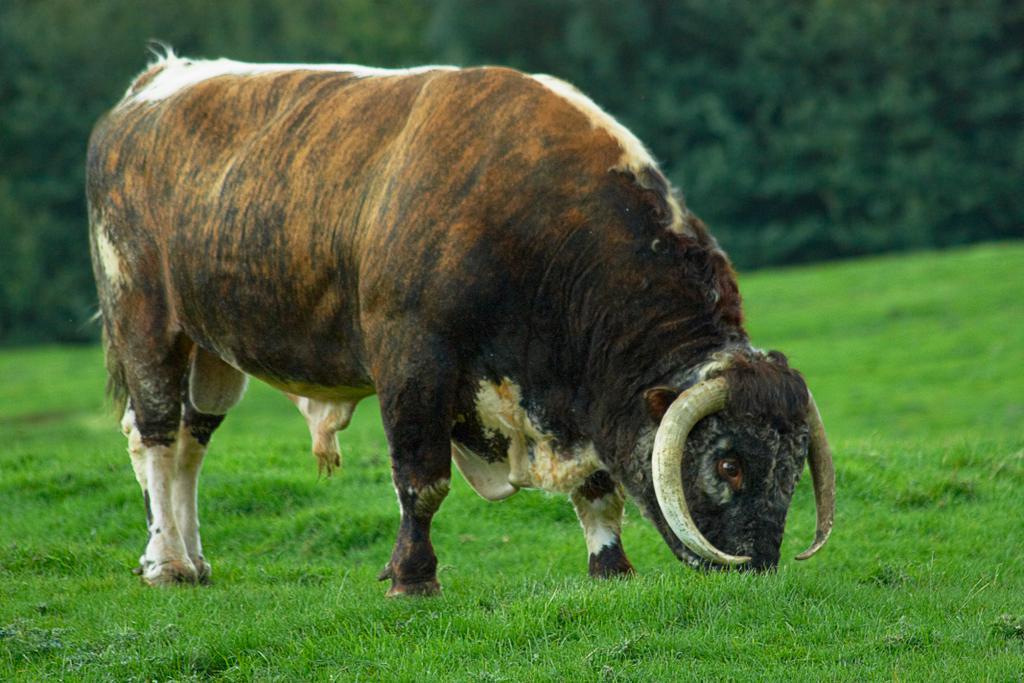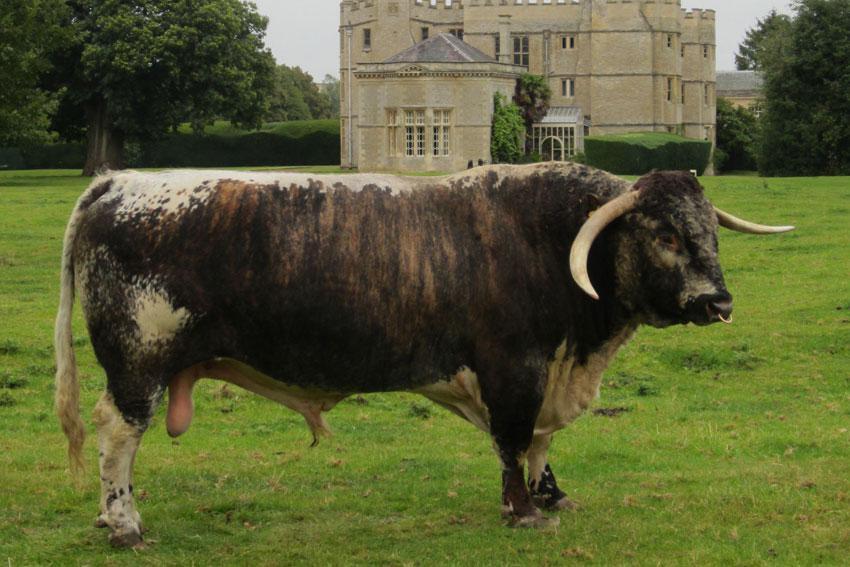The first image is the image on the left, the second image is the image on the right. For the images shown, is this caption "Each image contains one hooved animal standing in profile, each animal is an adult cow with horns, and the animals on the left and right have their bodies turned in the same direction." true? Answer yes or no. Yes. The first image is the image on the left, the second image is the image on the right. Given the left and right images, does the statement "One large animal is eating grass near a pond." hold true? Answer yes or no. No. 